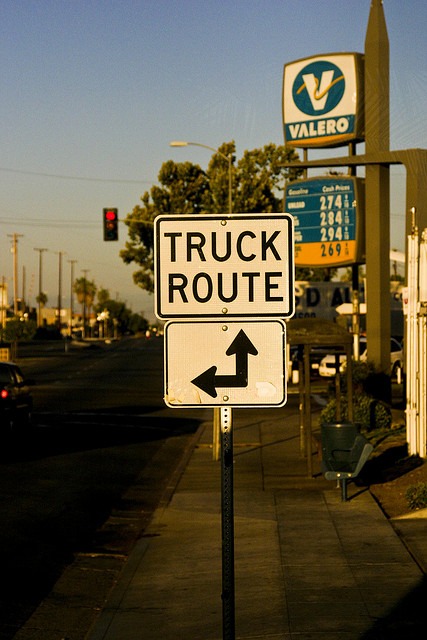<image>What is on green object on the white sign? I am not sure what is on the green object on the white sign. It could be letters, a logo, or a 'v'. What is on green object on the white sign? I don't know what is on the green object on the white sign. It can be a pole, letters or a logo. 